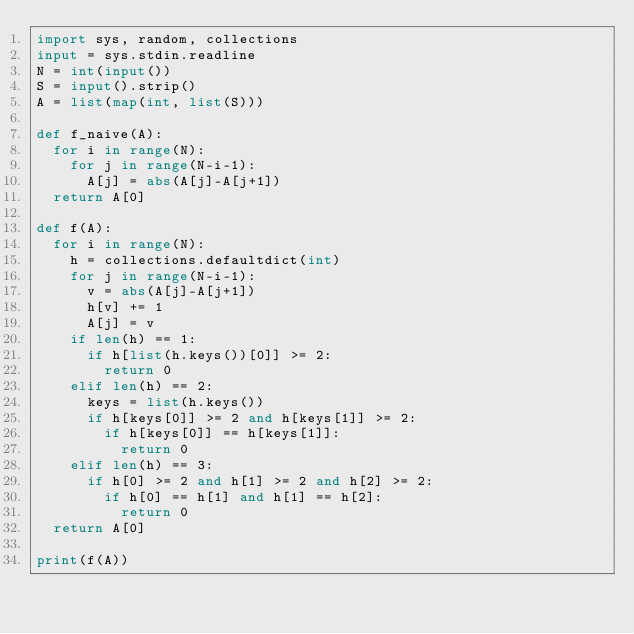<code> <loc_0><loc_0><loc_500><loc_500><_Python_>import sys, random, collections
input = sys.stdin.readline
N = int(input())
S = input().strip()
A = list(map(int, list(S)))

def f_naive(A):
  for i in range(N):
    for j in range(N-i-1):
      A[j] = abs(A[j]-A[j+1])
  return A[0]

def f(A):
  for i in range(N):
    h = collections.defaultdict(int)
    for j in range(N-i-1):
      v = abs(A[j]-A[j+1])
      h[v] += 1
      A[j] = v
    if len(h) == 1:
      if h[list(h.keys())[0]] >= 2:
        return 0
    elif len(h) == 2:
      keys = list(h.keys())
      if h[keys[0]] >= 2 and h[keys[1]] >= 2:
        if h[keys[0]] == h[keys[1]]:
          return 0
    elif len(h) == 3:
      if h[0] >= 2 and h[1] >= 2 and h[2] >= 2:
        if h[0] == h[1] and h[1] == h[2]:
          return 0
  return A[0]

print(f(A))</code> 